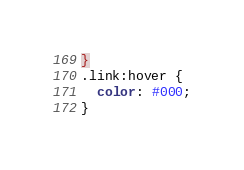<code> <loc_0><loc_0><loc_500><loc_500><_CSS_>}
.link:hover {
  color: #000;
}
</code> 